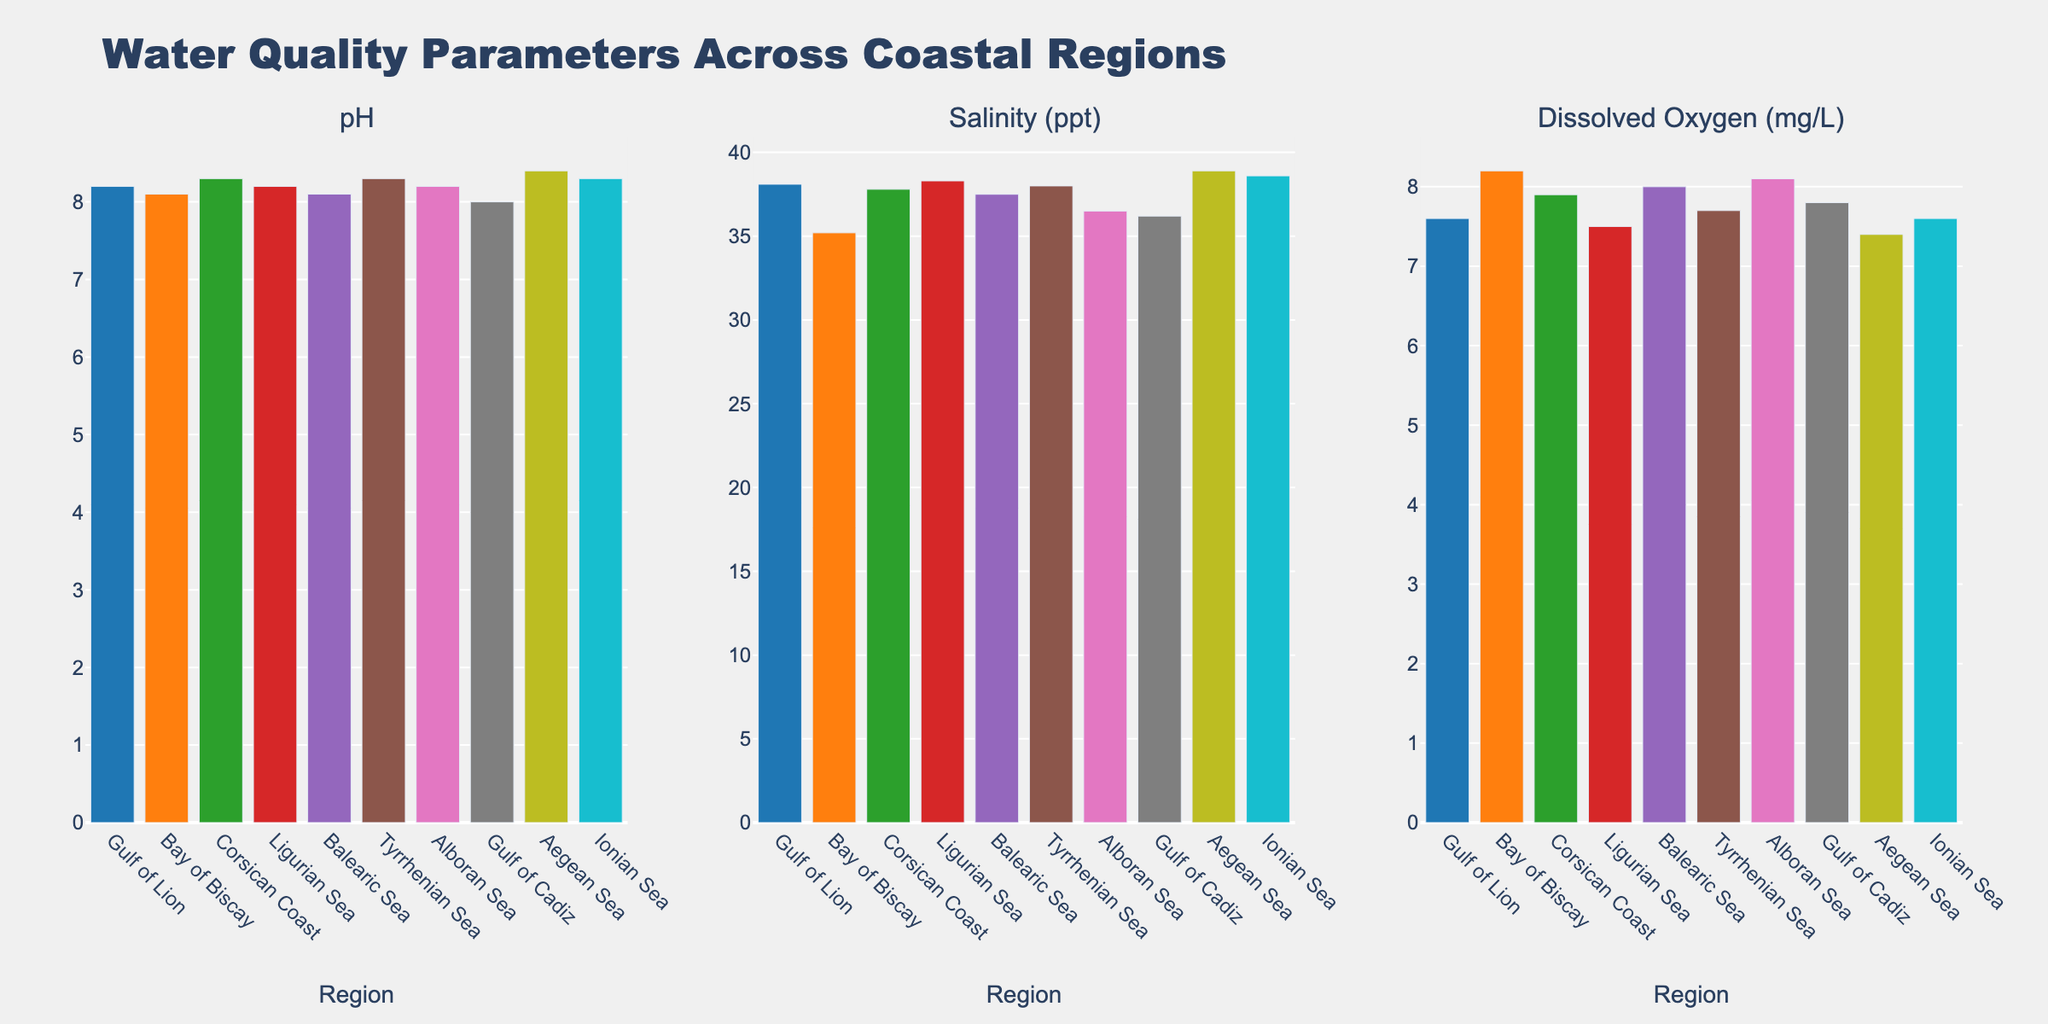Which region has the highest pH level? The highest pH level can be identified by looking at the height of the bars in the pH subplot and finding the tallest one. The Aegean Sea has the highest pH at 8.4.
Answer: Aegean Sea Which region has the lowest salinity? To find the region with the lowest salinity, compare the heights of the bars in the Salinity (ppt) subplot. The Gulf of Cadiz has the lowest salinity at 36.2.
Answer: Gulf of Cadiz What is the difference in dissolved oxygen levels between the Bay of Biscay and the Ligurian Sea? To determine the difference, subtract the dissolved oxygen level of the Ligurian Sea (7.5 mg/L) from that of the Bay of Biscay (8.2 mg/L). The difference is 8.2 - 7.5 = 0.7 mg/L.
Answer: 0.7 mg/L Which regions have the same pH level? By observing the heights of the bars in the pH subplot, the Gulf of Lion (8.2), Ligurian Sea (8.2), and Alboran Sea (8.2) have the same pH levels.
Answer: Gulf of Lion, Ligurian Sea, Alboran Sea Rank the regions in descending order of dissolved oxygen levels. To rank the regions, list the bars' heights in the Dissolved Oxygen (mg/L) subplot from highest to lowest: Bay of Biscay (8.2), Alboran Sea (8.1), Balearic Sea (8.0), Gulf of Cadiz (7.8), Tyrrhenian Sea (7.7), Gulf of Lion (7.6), Ionian Sea (7.6), Corsican Coast (7.9), Ligurian Sea (7.5), Aegean Sea (7.4).
Answer: Bay of Biscay, Alboran Sea, Balearic Sea, Gulf of Cadiz, Tyrrhenian Sea, Gulf of Lion, Ionian Sea, Corsican Coast, Ligurian Sea, Aegean Sea Which region shows the widest range in pH from the average pH value? First calculate the average pH by summing all pH values and dividing by the number of regions: (8.2+8.1+8.3+8.2+8.1+8.3+8.2+8.0+8.4+8.3) / 10 = 82.3 / 10 = 8.23. Then, subtract the average from each region's pH and find the maximum absolute difference. The Aegean Sea has the highest difference of
Answer: Aegean Sea If we consider regions with salinity greater than 38 ppt, how many regions fall into this category? Count the number of bars with heights greater than 38 in the Salinity (ppt) subplot: Gulf of Lion (38.1), Ligurian Sea (38.3), Aegean Sea (38.9), Ionian Sea (38.6), Tyrrhenian Sea (38.0).
Answer: 5 regions What is the combined pH level of the Corsican Coast and Tyrrhenian Sea? Sum the pH levels of the Corsican Coast (8.3) and Tyrrhenian Sea (8.3): 8.3 + 8.3 = 16.6
Answer: 16.6 